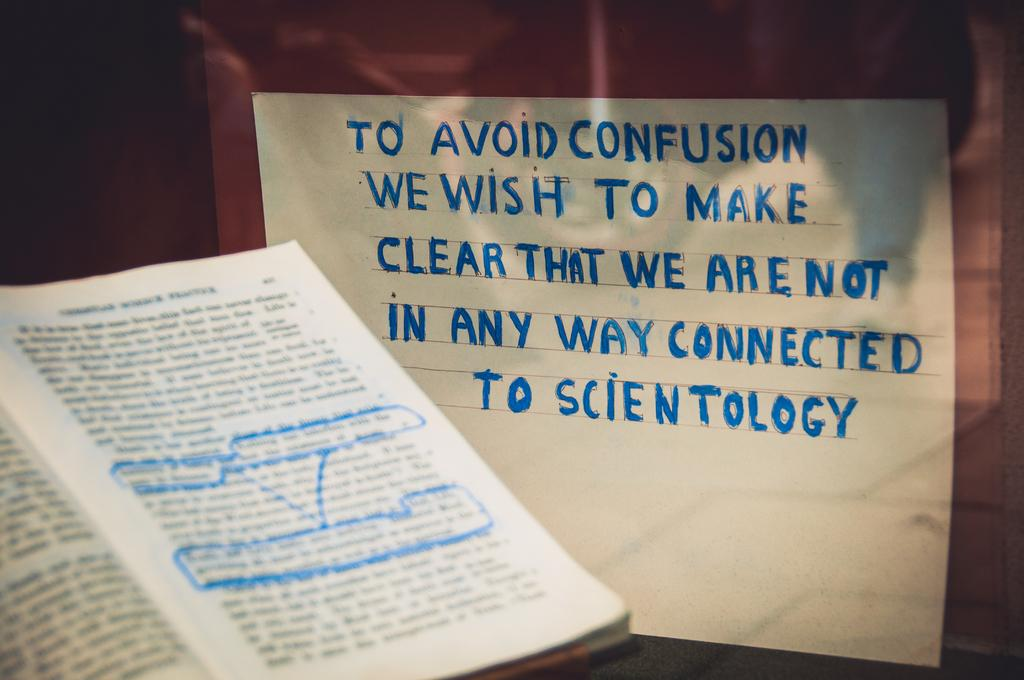Provide a one-sentence caption for the provided image. A highlighed book sits on a table next to a sign that says they are not connected to scientology. 